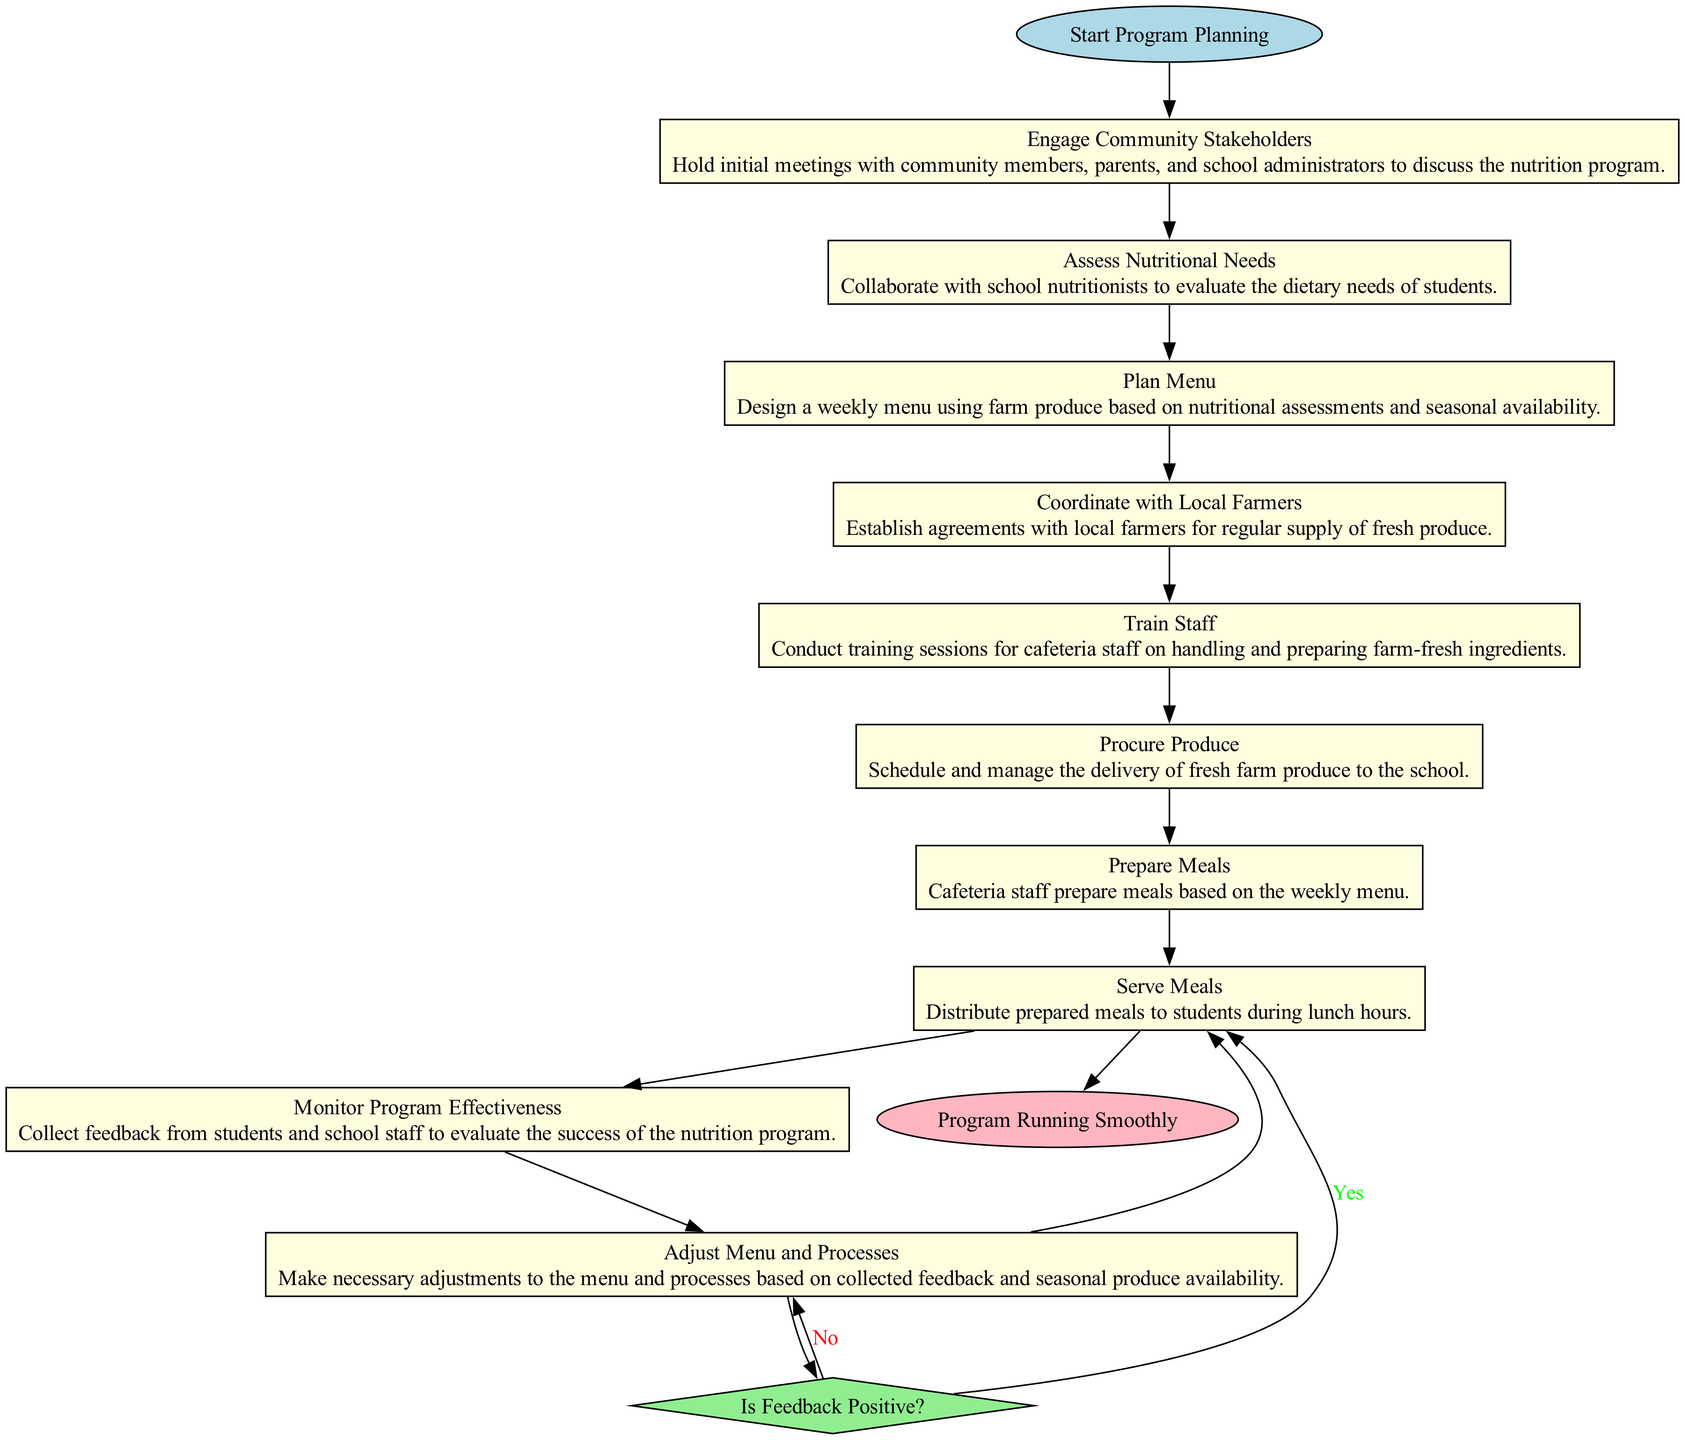What is the starting activity of the program? The starting activity, as indicated in the diagram, is labeled as "Start Program Planning." Therefore, the first step of the workflow is planning the program's initiation.
Answer: Start Program Planning How many activities are listed in the diagram? By counting the activities outlined in the diagram, we find there are ten distinct activities involving community engagement, assessing needs, and meal preparation among others.
Answer: 10 What is the end goal of the program? The end node in the diagram signifies that the final target is to have "Program Running Smoothly," which indicates successful completion and implementation of the school nutrition program.
Answer: Program Running Smoothly What task is associated with "Train Staff"? For the "Train Staff" activity, the task is to "Conduct training sessions for cafeteria staff on handling and preparing farm-fresh ingredients," essential for proper food preparation.
Answer: Conduct training sessions for cafeteria staff on handling and preparing farm-fresh ingredients What happens if feedback is negative? According to the decision point, if feedback is negative, it prompts the action to "Adjust Menu and Processes," indicating a need for revisions in response to concerns raised during monitoring.
Answer: Adjust Menu and Processes How does the program ensure it meets students' needs? The program evaluates students' dietary requirements through the "Assess Nutritional Needs" activity which involves collaboration with school nutritionists to understand dietary needs before moving forward with menu planning.
Answer: Collaborate with school nutritionists Which activity directly follows "Serve Meals"? After "Serve Meals," the next activity in sequence is "Monitor Program Effectiveness," showing the importance of assessing how well students receive the meals provided.
Answer: Monitor Program Effectiveness What is the decision point in the diagram? The decision point in the diagram is labeled "Is Feedback Positive?" which serves as a critical checkpoint to determine the next steps based on gathered feedback.
Answer: Is Feedback Positive? How does the program utilize farm produce in meal preparation? The process involves multiple steps such as "Plan Menu," where a weekly menu is designed using available farm produce, followed by "Procure Produce" to ensure fresh ingredients are used for meal preparation.
Answer: Design a weekly menu using farm produce 